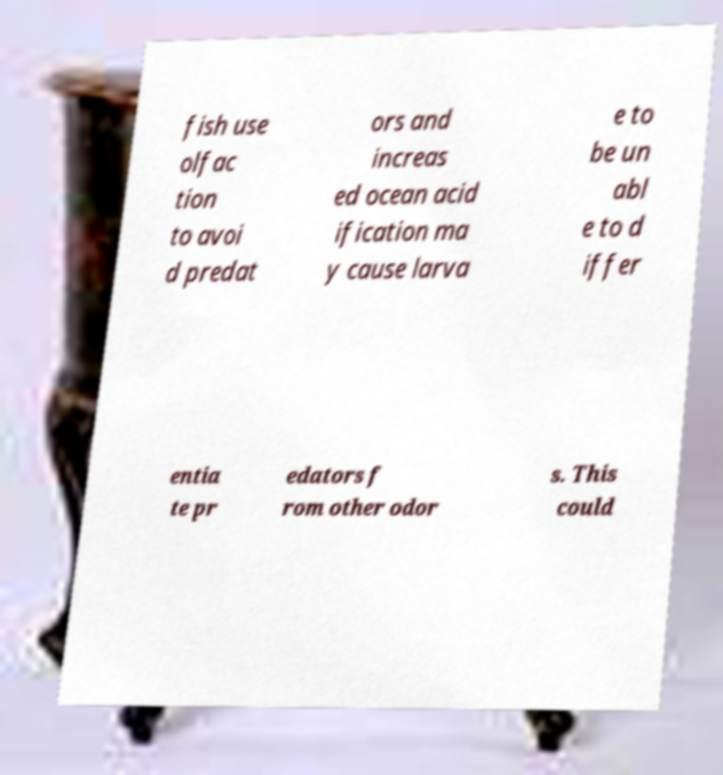Can you accurately transcribe the text from the provided image for me? fish use olfac tion to avoi d predat ors and increas ed ocean acid ification ma y cause larva e to be un abl e to d iffer entia te pr edators f rom other odor s. This could 